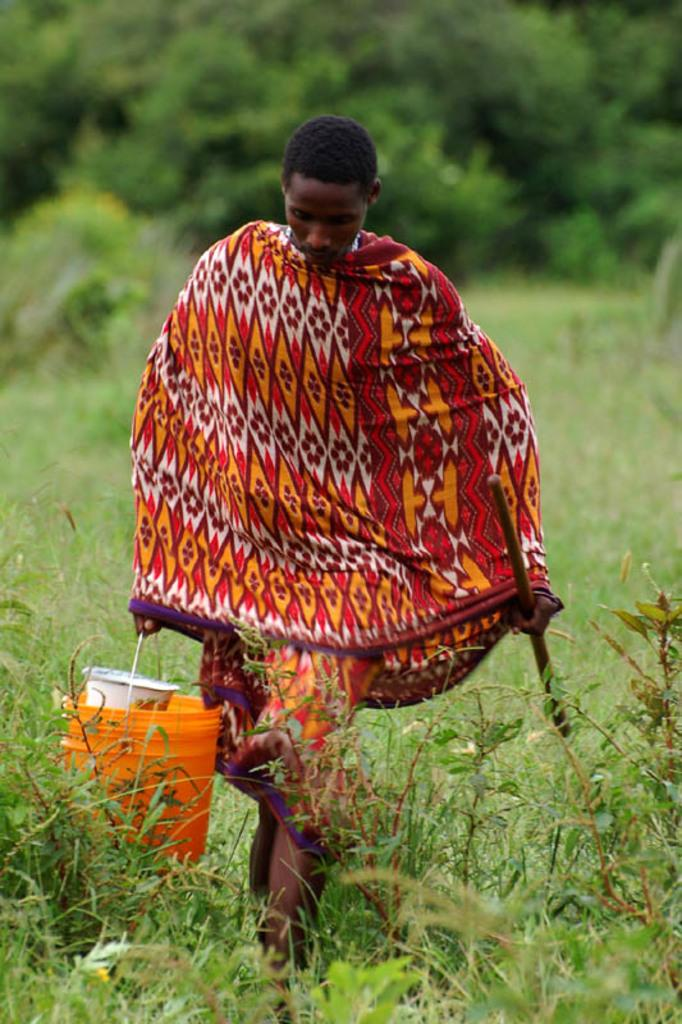What is the main subject of the picture? The main subject of the picture is a man. What is the man holding in one hand? The man is holding a stick in one hand. What is the man holding in the other hand? The man is holding a bucket in the other hand. What type of terrain is visible in the image? There is grass on the ground in the image. What other vegetation can be seen in the image? There are plants on the ground in the image. What is visible in the background of the image? There are trees in the background of the image. What type of park can be seen in the image? There is no park present in the image; it features a man holding a stick and a bucket, with grass, plants, and trees visible. What kind of boot is the carpenter wearing in the image? There is no carpenter or boot present in the image. 